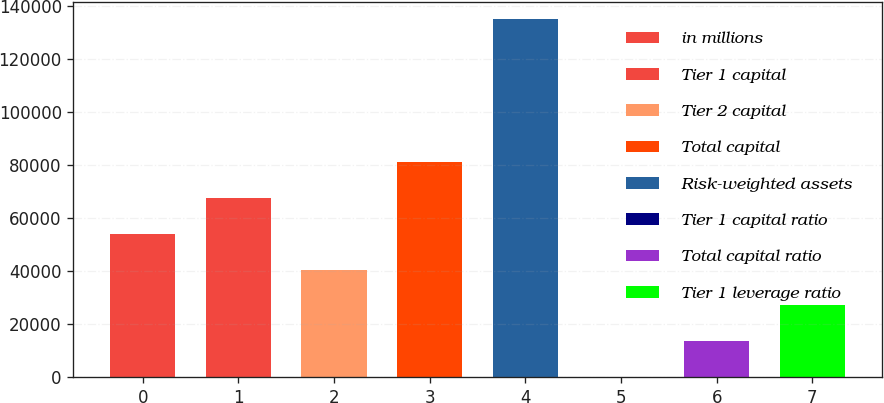<chart> <loc_0><loc_0><loc_500><loc_500><bar_chart><fcel>in millions<fcel>Tier 1 capital<fcel>Tier 2 capital<fcel>Total capital<fcel>Risk-weighted assets<fcel>Tier 1 capital ratio<fcel>Total capital ratio<fcel>Tier 1 leverage ratio<nl><fcel>53982.9<fcel>67474.9<fcel>40490.9<fcel>80967<fcel>134935<fcel>14.9<fcel>13506.9<fcel>26998.9<nl></chart> 